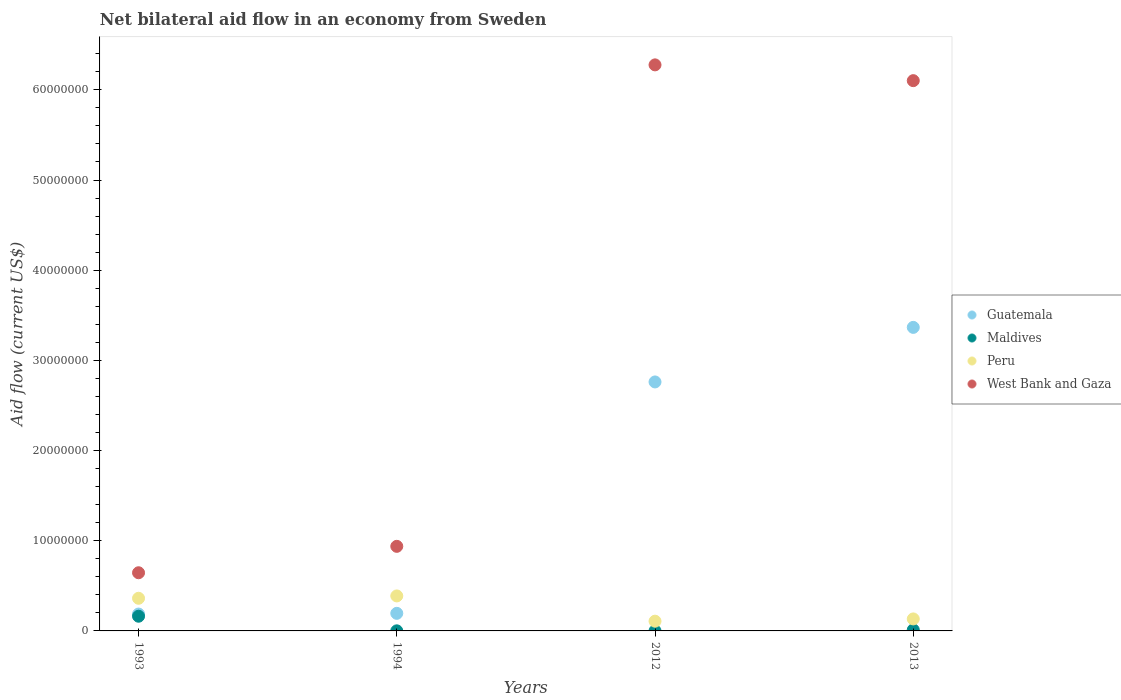How many different coloured dotlines are there?
Offer a very short reply. 4. What is the net bilateral aid flow in Maldives in 2012?
Offer a very short reply. 10000. Across all years, what is the maximum net bilateral aid flow in Maldives?
Offer a very short reply. 1.63e+06. Across all years, what is the minimum net bilateral aid flow in West Bank and Gaza?
Your response must be concise. 6.45e+06. What is the total net bilateral aid flow in West Bank and Gaza in the graph?
Provide a succinct answer. 1.40e+08. What is the difference between the net bilateral aid flow in West Bank and Gaza in 1993 and that in 2013?
Provide a short and direct response. -5.46e+07. What is the difference between the net bilateral aid flow in West Bank and Gaza in 1994 and the net bilateral aid flow in Peru in 2012?
Offer a terse response. 8.30e+06. What is the average net bilateral aid flow in Guatemala per year?
Provide a succinct answer. 1.63e+07. In the year 1994, what is the difference between the net bilateral aid flow in Peru and net bilateral aid flow in Maldives?
Keep it short and to the point. 3.87e+06. What is the ratio of the net bilateral aid flow in Maldives in 1993 to that in 1994?
Keep it short and to the point. 163. Is the net bilateral aid flow in Maldives in 1994 less than that in 2012?
Make the answer very short. No. Is the difference between the net bilateral aid flow in Peru in 2012 and 2013 greater than the difference between the net bilateral aid flow in Maldives in 2012 and 2013?
Ensure brevity in your answer.  No. What is the difference between the highest and the lowest net bilateral aid flow in West Bank and Gaza?
Your answer should be compact. 5.63e+07. Is the sum of the net bilateral aid flow in Maldives in 2012 and 2013 greater than the maximum net bilateral aid flow in Guatemala across all years?
Give a very brief answer. No. How many dotlines are there?
Your answer should be compact. 4. What is the difference between two consecutive major ticks on the Y-axis?
Offer a terse response. 1.00e+07. Where does the legend appear in the graph?
Offer a very short reply. Center right. How many legend labels are there?
Ensure brevity in your answer.  4. How are the legend labels stacked?
Offer a very short reply. Vertical. What is the title of the graph?
Provide a succinct answer. Net bilateral aid flow in an economy from Sweden. What is the label or title of the Y-axis?
Offer a terse response. Aid flow (current US$). What is the Aid flow (current US$) in Guatemala in 1993?
Ensure brevity in your answer.  1.87e+06. What is the Aid flow (current US$) of Maldives in 1993?
Keep it short and to the point. 1.63e+06. What is the Aid flow (current US$) of Peru in 1993?
Your answer should be compact. 3.62e+06. What is the Aid flow (current US$) in West Bank and Gaza in 1993?
Make the answer very short. 6.45e+06. What is the Aid flow (current US$) of Guatemala in 1994?
Your answer should be very brief. 1.95e+06. What is the Aid flow (current US$) in Maldives in 1994?
Offer a very short reply. 10000. What is the Aid flow (current US$) in Peru in 1994?
Your response must be concise. 3.88e+06. What is the Aid flow (current US$) in West Bank and Gaza in 1994?
Offer a very short reply. 9.38e+06. What is the Aid flow (current US$) of Guatemala in 2012?
Give a very brief answer. 2.76e+07. What is the Aid flow (current US$) of Peru in 2012?
Your answer should be very brief. 1.08e+06. What is the Aid flow (current US$) in West Bank and Gaza in 2012?
Your response must be concise. 6.28e+07. What is the Aid flow (current US$) in Guatemala in 2013?
Make the answer very short. 3.37e+07. What is the Aid flow (current US$) of Peru in 2013?
Offer a very short reply. 1.33e+06. What is the Aid flow (current US$) in West Bank and Gaza in 2013?
Keep it short and to the point. 6.10e+07. Across all years, what is the maximum Aid flow (current US$) of Guatemala?
Your answer should be compact. 3.37e+07. Across all years, what is the maximum Aid flow (current US$) of Maldives?
Ensure brevity in your answer.  1.63e+06. Across all years, what is the maximum Aid flow (current US$) of Peru?
Make the answer very short. 3.88e+06. Across all years, what is the maximum Aid flow (current US$) in West Bank and Gaza?
Offer a terse response. 6.28e+07. Across all years, what is the minimum Aid flow (current US$) of Guatemala?
Keep it short and to the point. 1.87e+06. Across all years, what is the minimum Aid flow (current US$) of Maldives?
Make the answer very short. 10000. Across all years, what is the minimum Aid flow (current US$) in Peru?
Ensure brevity in your answer.  1.08e+06. Across all years, what is the minimum Aid flow (current US$) of West Bank and Gaza?
Make the answer very short. 6.45e+06. What is the total Aid flow (current US$) in Guatemala in the graph?
Offer a very short reply. 6.51e+07. What is the total Aid flow (current US$) of Maldives in the graph?
Give a very brief answer. 1.77e+06. What is the total Aid flow (current US$) of Peru in the graph?
Offer a terse response. 9.91e+06. What is the total Aid flow (current US$) in West Bank and Gaza in the graph?
Ensure brevity in your answer.  1.40e+08. What is the difference between the Aid flow (current US$) of Guatemala in 1993 and that in 1994?
Offer a very short reply. -8.00e+04. What is the difference between the Aid flow (current US$) of Maldives in 1993 and that in 1994?
Keep it short and to the point. 1.62e+06. What is the difference between the Aid flow (current US$) in Peru in 1993 and that in 1994?
Make the answer very short. -2.60e+05. What is the difference between the Aid flow (current US$) of West Bank and Gaza in 1993 and that in 1994?
Provide a succinct answer. -2.93e+06. What is the difference between the Aid flow (current US$) in Guatemala in 1993 and that in 2012?
Ensure brevity in your answer.  -2.57e+07. What is the difference between the Aid flow (current US$) of Maldives in 1993 and that in 2012?
Your answer should be compact. 1.62e+06. What is the difference between the Aid flow (current US$) of Peru in 1993 and that in 2012?
Give a very brief answer. 2.54e+06. What is the difference between the Aid flow (current US$) of West Bank and Gaza in 1993 and that in 2012?
Your answer should be very brief. -5.63e+07. What is the difference between the Aid flow (current US$) of Guatemala in 1993 and that in 2013?
Your answer should be very brief. -3.18e+07. What is the difference between the Aid flow (current US$) of Maldives in 1993 and that in 2013?
Provide a short and direct response. 1.51e+06. What is the difference between the Aid flow (current US$) in Peru in 1993 and that in 2013?
Your answer should be very brief. 2.29e+06. What is the difference between the Aid flow (current US$) of West Bank and Gaza in 1993 and that in 2013?
Keep it short and to the point. -5.46e+07. What is the difference between the Aid flow (current US$) of Guatemala in 1994 and that in 2012?
Keep it short and to the point. -2.57e+07. What is the difference between the Aid flow (current US$) in Maldives in 1994 and that in 2012?
Offer a very short reply. 0. What is the difference between the Aid flow (current US$) of Peru in 1994 and that in 2012?
Provide a succinct answer. 2.80e+06. What is the difference between the Aid flow (current US$) of West Bank and Gaza in 1994 and that in 2012?
Your answer should be compact. -5.34e+07. What is the difference between the Aid flow (current US$) in Guatemala in 1994 and that in 2013?
Make the answer very short. -3.17e+07. What is the difference between the Aid flow (current US$) of Peru in 1994 and that in 2013?
Your answer should be compact. 2.55e+06. What is the difference between the Aid flow (current US$) in West Bank and Gaza in 1994 and that in 2013?
Your answer should be compact. -5.16e+07. What is the difference between the Aid flow (current US$) of Guatemala in 2012 and that in 2013?
Provide a succinct answer. -6.05e+06. What is the difference between the Aid flow (current US$) in West Bank and Gaza in 2012 and that in 2013?
Offer a very short reply. 1.75e+06. What is the difference between the Aid flow (current US$) in Guatemala in 1993 and the Aid flow (current US$) in Maldives in 1994?
Your answer should be compact. 1.86e+06. What is the difference between the Aid flow (current US$) of Guatemala in 1993 and the Aid flow (current US$) of Peru in 1994?
Your answer should be very brief. -2.01e+06. What is the difference between the Aid flow (current US$) of Guatemala in 1993 and the Aid flow (current US$) of West Bank and Gaza in 1994?
Offer a terse response. -7.51e+06. What is the difference between the Aid flow (current US$) of Maldives in 1993 and the Aid flow (current US$) of Peru in 1994?
Your response must be concise. -2.25e+06. What is the difference between the Aid flow (current US$) of Maldives in 1993 and the Aid flow (current US$) of West Bank and Gaza in 1994?
Offer a very short reply. -7.75e+06. What is the difference between the Aid flow (current US$) in Peru in 1993 and the Aid flow (current US$) in West Bank and Gaza in 1994?
Your response must be concise. -5.76e+06. What is the difference between the Aid flow (current US$) in Guatemala in 1993 and the Aid flow (current US$) in Maldives in 2012?
Give a very brief answer. 1.86e+06. What is the difference between the Aid flow (current US$) of Guatemala in 1993 and the Aid flow (current US$) of Peru in 2012?
Offer a terse response. 7.90e+05. What is the difference between the Aid flow (current US$) in Guatemala in 1993 and the Aid flow (current US$) in West Bank and Gaza in 2012?
Make the answer very short. -6.09e+07. What is the difference between the Aid flow (current US$) in Maldives in 1993 and the Aid flow (current US$) in West Bank and Gaza in 2012?
Provide a short and direct response. -6.11e+07. What is the difference between the Aid flow (current US$) of Peru in 1993 and the Aid flow (current US$) of West Bank and Gaza in 2012?
Offer a very short reply. -5.92e+07. What is the difference between the Aid flow (current US$) in Guatemala in 1993 and the Aid flow (current US$) in Maldives in 2013?
Your answer should be compact. 1.75e+06. What is the difference between the Aid flow (current US$) in Guatemala in 1993 and the Aid flow (current US$) in Peru in 2013?
Give a very brief answer. 5.40e+05. What is the difference between the Aid flow (current US$) of Guatemala in 1993 and the Aid flow (current US$) of West Bank and Gaza in 2013?
Offer a terse response. -5.92e+07. What is the difference between the Aid flow (current US$) of Maldives in 1993 and the Aid flow (current US$) of Peru in 2013?
Ensure brevity in your answer.  3.00e+05. What is the difference between the Aid flow (current US$) in Maldives in 1993 and the Aid flow (current US$) in West Bank and Gaza in 2013?
Provide a succinct answer. -5.94e+07. What is the difference between the Aid flow (current US$) of Peru in 1993 and the Aid flow (current US$) of West Bank and Gaza in 2013?
Your response must be concise. -5.74e+07. What is the difference between the Aid flow (current US$) of Guatemala in 1994 and the Aid flow (current US$) of Maldives in 2012?
Your response must be concise. 1.94e+06. What is the difference between the Aid flow (current US$) in Guatemala in 1994 and the Aid flow (current US$) in Peru in 2012?
Ensure brevity in your answer.  8.70e+05. What is the difference between the Aid flow (current US$) in Guatemala in 1994 and the Aid flow (current US$) in West Bank and Gaza in 2012?
Your answer should be compact. -6.08e+07. What is the difference between the Aid flow (current US$) in Maldives in 1994 and the Aid flow (current US$) in Peru in 2012?
Offer a very short reply. -1.07e+06. What is the difference between the Aid flow (current US$) of Maldives in 1994 and the Aid flow (current US$) of West Bank and Gaza in 2012?
Your answer should be very brief. -6.28e+07. What is the difference between the Aid flow (current US$) in Peru in 1994 and the Aid flow (current US$) in West Bank and Gaza in 2012?
Your response must be concise. -5.89e+07. What is the difference between the Aid flow (current US$) of Guatemala in 1994 and the Aid flow (current US$) of Maldives in 2013?
Give a very brief answer. 1.83e+06. What is the difference between the Aid flow (current US$) in Guatemala in 1994 and the Aid flow (current US$) in Peru in 2013?
Make the answer very short. 6.20e+05. What is the difference between the Aid flow (current US$) of Guatemala in 1994 and the Aid flow (current US$) of West Bank and Gaza in 2013?
Keep it short and to the point. -5.91e+07. What is the difference between the Aid flow (current US$) in Maldives in 1994 and the Aid flow (current US$) in Peru in 2013?
Offer a very short reply. -1.32e+06. What is the difference between the Aid flow (current US$) in Maldives in 1994 and the Aid flow (current US$) in West Bank and Gaza in 2013?
Your answer should be compact. -6.10e+07. What is the difference between the Aid flow (current US$) in Peru in 1994 and the Aid flow (current US$) in West Bank and Gaza in 2013?
Keep it short and to the point. -5.71e+07. What is the difference between the Aid flow (current US$) in Guatemala in 2012 and the Aid flow (current US$) in Maldives in 2013?
Keep it short and to the point. 2.75e+07. What is the difference between the Aid flow (current US$) of Guatemala in 2012 and the Aid flow (current US$) of Peru in 2013?
Provide a short and direct response. 2.63e+07. What is the difference between the Aid flow (current US$) in Guatemala in 2012 and the Aid flow (current US$) in West Bank and Gaza in 2013?
Provide a succinct answer. -3.34e+07. What is the difference between the Aid flow (current US$) of Maldives in 2012 and the Aid flow (current US$) of Peru in 2013?
Keep it short and to the point. -1.32e+06. What is the difference between the Aid flow (current US$) in Maldives in 2012 and the Aid flow (current US$) in West Bank and Gaza in 2013?
Offer a terse response. -6.10e+07. What is the difference between the Aid flow (current US$) of Peru in 2012 and the Aid flow (current US$) of West Bank and Gaza in 2013?
Give a very brief answer. -5.99e+07. What is the average Aid flow (current US$) of Guatemala per year?
Your answer should be compact. 1.63e+07. What is the average Aid flow (current US$) of Maldives per year?
Offer a very short reply. 4.42e+05. What is the average Aid flow (current US$) of Peru per year?
Give a very brief answer. 2.48e+06. What is the average Aid flow (current US$) in West Bank and Gaza per year?
Provide a succinct answer. 3.49e+07. In the year 1993, what is the difference between the Aid flow (current US$) in Guatemala and Aid flow (current US$) in Maldives?
Your answer should be compact. 2.40e+05. In the year 1993, what is the difference between the Aid flow (current US$) of Guatemala and Aid flow (current US$) of Peru?
Your response must be concise. -1.75e+06. In the year 1993, what is the difference between the Aid flow (current US$) in Guatemala and Aid flow (current US$) in West Bank and Gaza?
Your response must be concise. -4.58e+06. In the year 1993, what is the difference between the Aid flow (current US$) of Maldives and Aid flow (current US$) of Peru?
Your answer should be very brief. -1.99e+06. In the year 1993, what is the difference between the Aid flow (current US$) of Maldives and Aid flow (current US$) of West Bank and Gaza?
Offer a terse response. -4.82e+06. In the year 1993, what is the difference between the Aid flow (current US$) of Peru and Aid flow (current US$) of West Bank and Gaza?
Offer a very short reply. -2.83e+06. In the year 1994, what is the difference between the Aid flow (current US$) in Guatemala and Aid flow (current US$) in Maldives?
Offer a terse response. 1.94e+06. In the year 1994, what is the difference between the Aid flow (current US$) in Guatemala and Aid flow (current US$) in Peru?
Make the answer very short. -1.93e+06. In the year 1994, what is the difference between the Aid flow (current US$) of Guatemala and Aid flow (current US$) of West Bank and Gaza?
Your answer should be compact. -7.43e+06. In the year 1994, what is the difference between the Aid flow (current US$) of Maldives and Aid flow (current US$) of Peru?
Keep it short and to the point. -3.87e+06. In the year 1994, what is the difference between the Aid flow (current US$) in Maldives and Aid flow (current US$) in West Bank and Gaza?
Offer a very short reply. -9.37e+06. In the year 1994, what is the difference between the Aid flow (current US$) in Peru and Aid flow (current US$) in West Bank and Gaza?
Provide a short and direct response. -5.50e+06. In the year 2012, what is the difference between the Aid flow (current US$) of Guatemala and Aid flow (current US$) of Maldives?
Provide a succinct answer. 2.76e+07. In the year 2012, what is the difference between the Aid flow (current US$) of Guatemala and Aid flow (current US$) of Peru?
Your answer should be compact. 2.65e+07. In the year 2012, what is the difference between the Aid flow (current US$) in Guatemala and Aid flow (current US$) in West Bank and Gaza?
Offer a terse response. -3.52e+07. In the year 2012, what is the difference between the Aid flow (current US$) of Maldives and Aid flow (current US$) of Peru?
Ensure brevity in your answer.  -1.07e+06. In the year 2012, what is the difference between the Aid flow (current US$) in Maldives and Aid flow (current US$) in West Bank and Gaza?
Make the answer very short. -6.28e+07. In the year 2012, what is the difference between the Aid flow (current US$) of Peru and Aid flow (current US$) of West Bank and Gaza?
Ensure brevity in your answer.  -6.17e+07. In the year 2013, what is the difference between the Aid flow (current US$) in Guatemala and Aid flow (current US$) in Maldives?
Your answer should be very brief. 3.35e+07. In the year 2013, what is the difference between the Aid flow (current US$) of Guatemala and Aid flow (current US$) of Peru?
Provide a succinct answer. 3.23e+07. In the year 2013, what is the difference between the Aid flow (current US$) in Guatemala and Aid flow (current US$) in West Bank and Gaza?
Provide a short and direct response. -2.74e+07. In the year 2013, what is the difference between the Aid flow (current US$) of Maldives and Aid flow (current US$) of Peru?
Make the answer very short. -1.21e+06. In the year 2013, what is the difference between the Aid flow (current US$) in Maldives and Aid flow (current US$) in West Bank and Gaza?
Your answer should be compact. -6.09e+07. In the year 2013, what is the difference between the Aid flow (current US$) in Peru and Aid flow (current US$) in West Bank and Gaza?
Provide a succinct answer. -5.97e+07. What is the ratio of the Aid flow (current US$) of Guatemala in 1993 to that in 1994?
Keep it short and to the point. 0.96. What is the ratio of the Aid flow (current US$) in Maldives in 1993 to that in 1994?
Offer a terse response. 163. What is the ratio of the Aid flow (current US$) of Peru in 1993 to that in 1994?
Your answer should be compact. 0.93. What is the ratio of the Aid flow (current US$) in West Bank and Gaza in 1993 to that in 1994?
Provide a succinct answer. 0.69. What is the ratio of the Aid flow (current US$) of Guatemala in 1993 to that in 2012?
Your answer should be very brief. 0.07. What is the ratio of the Aid flow (current US$) of Maldives in 1993 to that in 2012?
Offer a terse response. 163. What is the ratio of the Aid flow (current US$) in Peru in 1993 to that in 2012?
Provide a succinct answer. 3.35. What is the ratio of the Aid flow (current US$) in West Bank and Gaza in 1993 to that in 2012?
Ensure brevity in your answer.  0.1. What is the ratio of the Aid flow (current US$) in Guatemala in 1993 to that in 2013?
Offer a very short reply. 0.06. What is the ratio of the Aid flow (current US$) in Maldives in 1993 to that in 2013?
Ensure brevity in your answer.  13.58. What is the ratio of the Aid flow (current US$) in Peru in 1993 to that in 2013?
Your response must be concise. 2.72. What is the ratio of the Aid flow (current US$) of West Bank and Gaza in 1993 to that in 2013?
Give a very brief answer. 0.11. What is the ratio of the Aid flow (current US$) in Guatemala in 1994 to that in 2012?
Keep it short and to the point. 0.07. What is the ratio of the Aid flow (current US$) in Peru in 1994 to that in 2012?
Keep it short and to the point. 3.59. What is the ratio of the Aid flow (current US$) of West Bank and Gaza in 1994 to that in 2012?
Offer a terse response. 0.15. What is the ratio of the Aid flow (current US$) of Guatemala in 1994 to that in 2013?
Provide a succinct answer. 0.06. What is the ratio of the Aid flow (current US$) of Maldives in 1994 to that in 2013?
Provide a succinct answer. 0.08. What is the ratio of the Aid flow (current US$) in Peru in 1994 to that in 2013?
Provide a short and direct response. 2.92. What is the ratio of the Aid flow (current US$) in West Bank and Gaza in 1994 to that in 2013?
Give a very brief answer. 0.15. What is the ratio of the Aid flow (current US$) of Guatemala in 2012 to that in 2013?
Give a very brief answer. 0.82. What is the ratio of the Aid flow (current US$) in Maldives in 2012 to that in 2013?
Your response must be concise. 0.08. What is the ratio of the Aid flow (current US$) of Peru in 2012 to that in 2013?
Ensure brevity in your answer.  0.81. What is the ratio of the Aid flow (current US$) of West Bank and Gaza in 2012 to that in 2013?
Provide a short and direct response. 1.03. What is the difference between the highest and the second highest Aid flow (current US$) in Guatemala?
Your answer should be compact. 6.05e+06. What is the difference between the highest and the second highest Aid flow (current US$) of Maldives?
Ensure brevity in your answer.  1.51e+06. What is the difference between the highest and the second highest Aid flow (current US$) in Peru?
Give a very brief answer. 2.60e+05. What is the difference between the highest and the second highest Aid flow (current US$) of West Bank and Gaza?
Give a very brief answer. 1.75e+06. What is the difference between the highest and the lowest Aid flow (current US$) in Guatemala?
Provide a short and direct response. 3.18e+07. What is the difference between the highest and the lowest Aid flow (current US$) of Maldives?
Provide a succinct answer. 1.62e+06. What is the difference between the highest and the lowest Aid flow (current US$) in Peru?
Your response must be concise. 2.80e+06. What is the difference between the highest and the lowest Aid flow (current US$) in West Bank and Gaza?
Ensure brevity in your answer.  5.63e+07. 